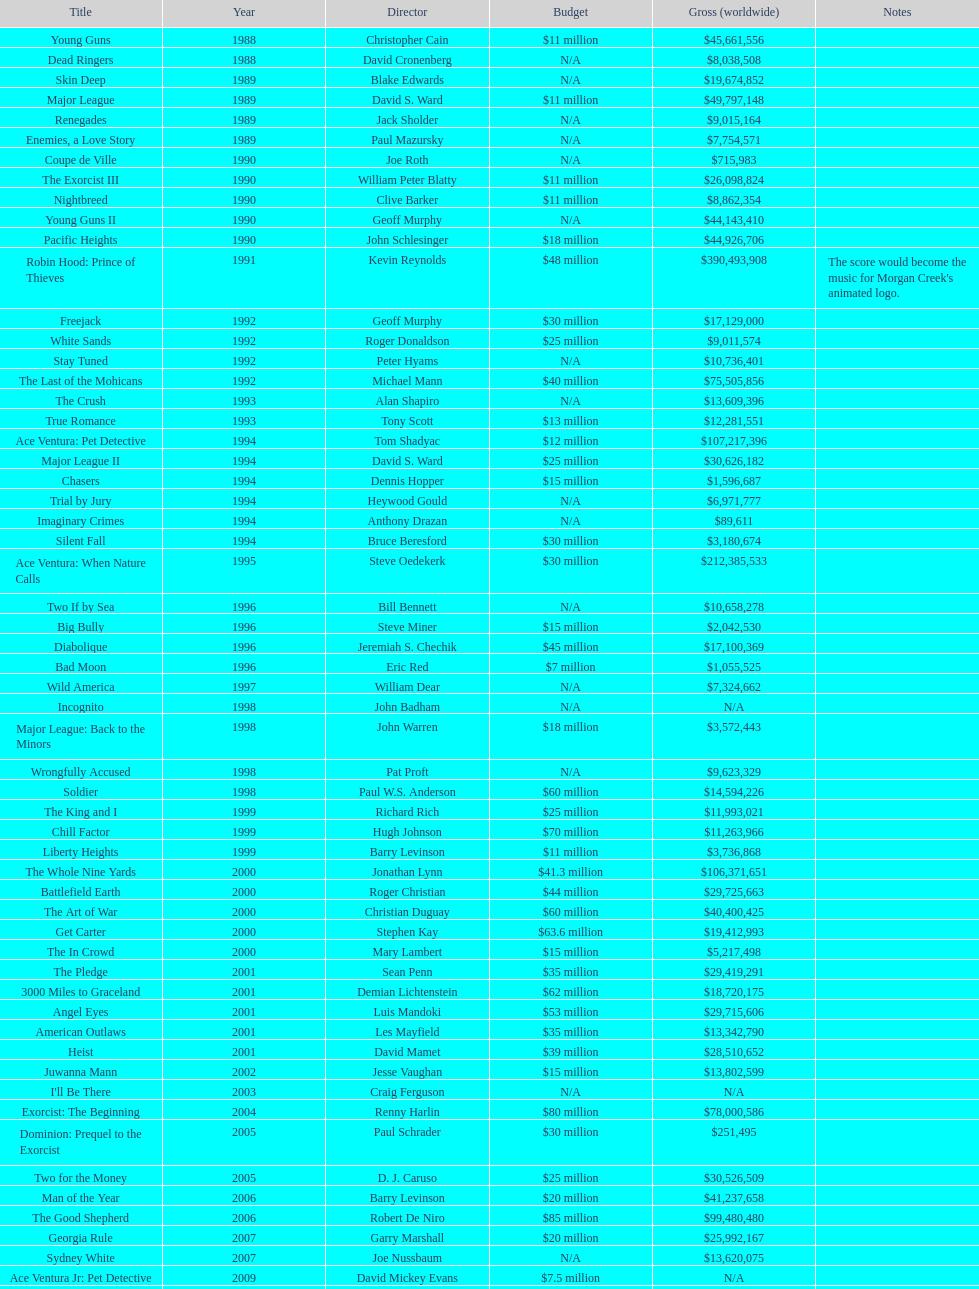How many films did morgan creek make in 2006? 2. 